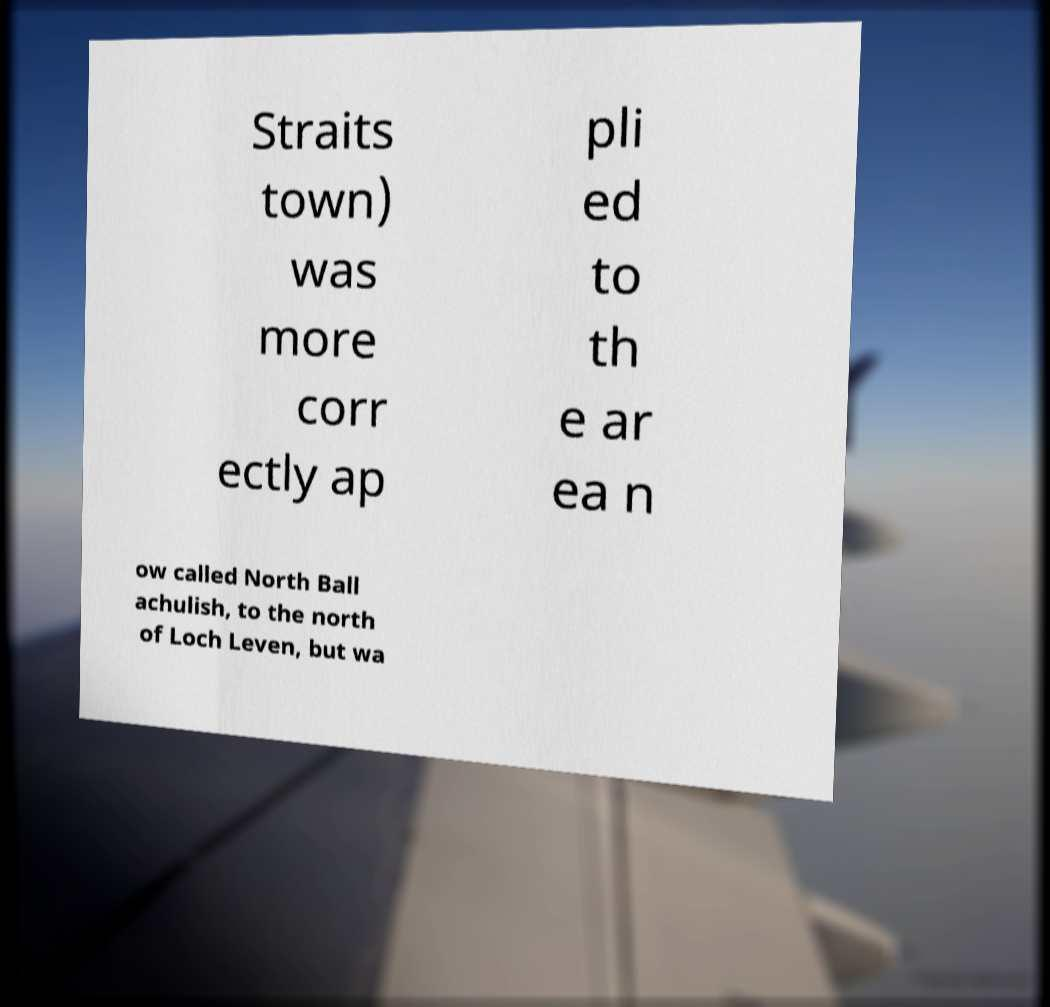Please identify and transcribe the text found in this image. Straits town) was more corr ectly ap pli ed to th e ar ea n ow called North Ball achulish, to the north of Loch Leven, but wa 